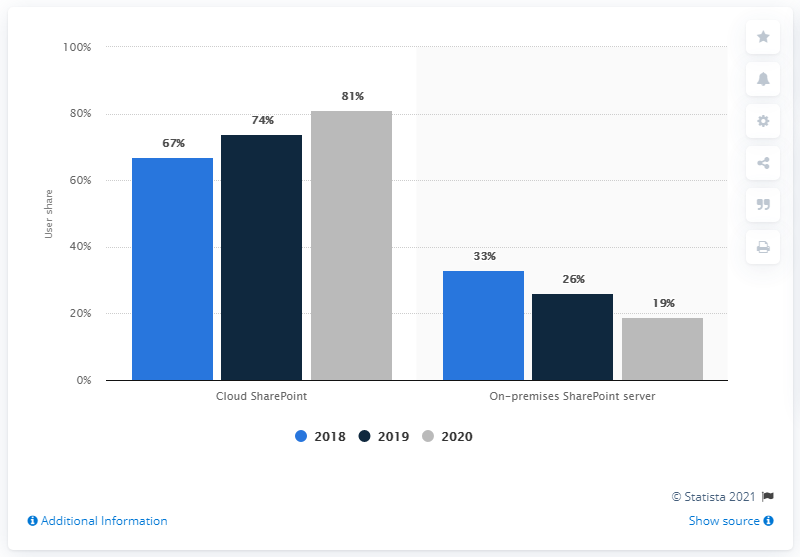Specify some key components in this picture. The difference between the highest and lowest dark blue bar is 48. Microsoft SharePoint servers had the highest deployment breakdown of 81% in 2018 and 82% in 2020 worldwide. 